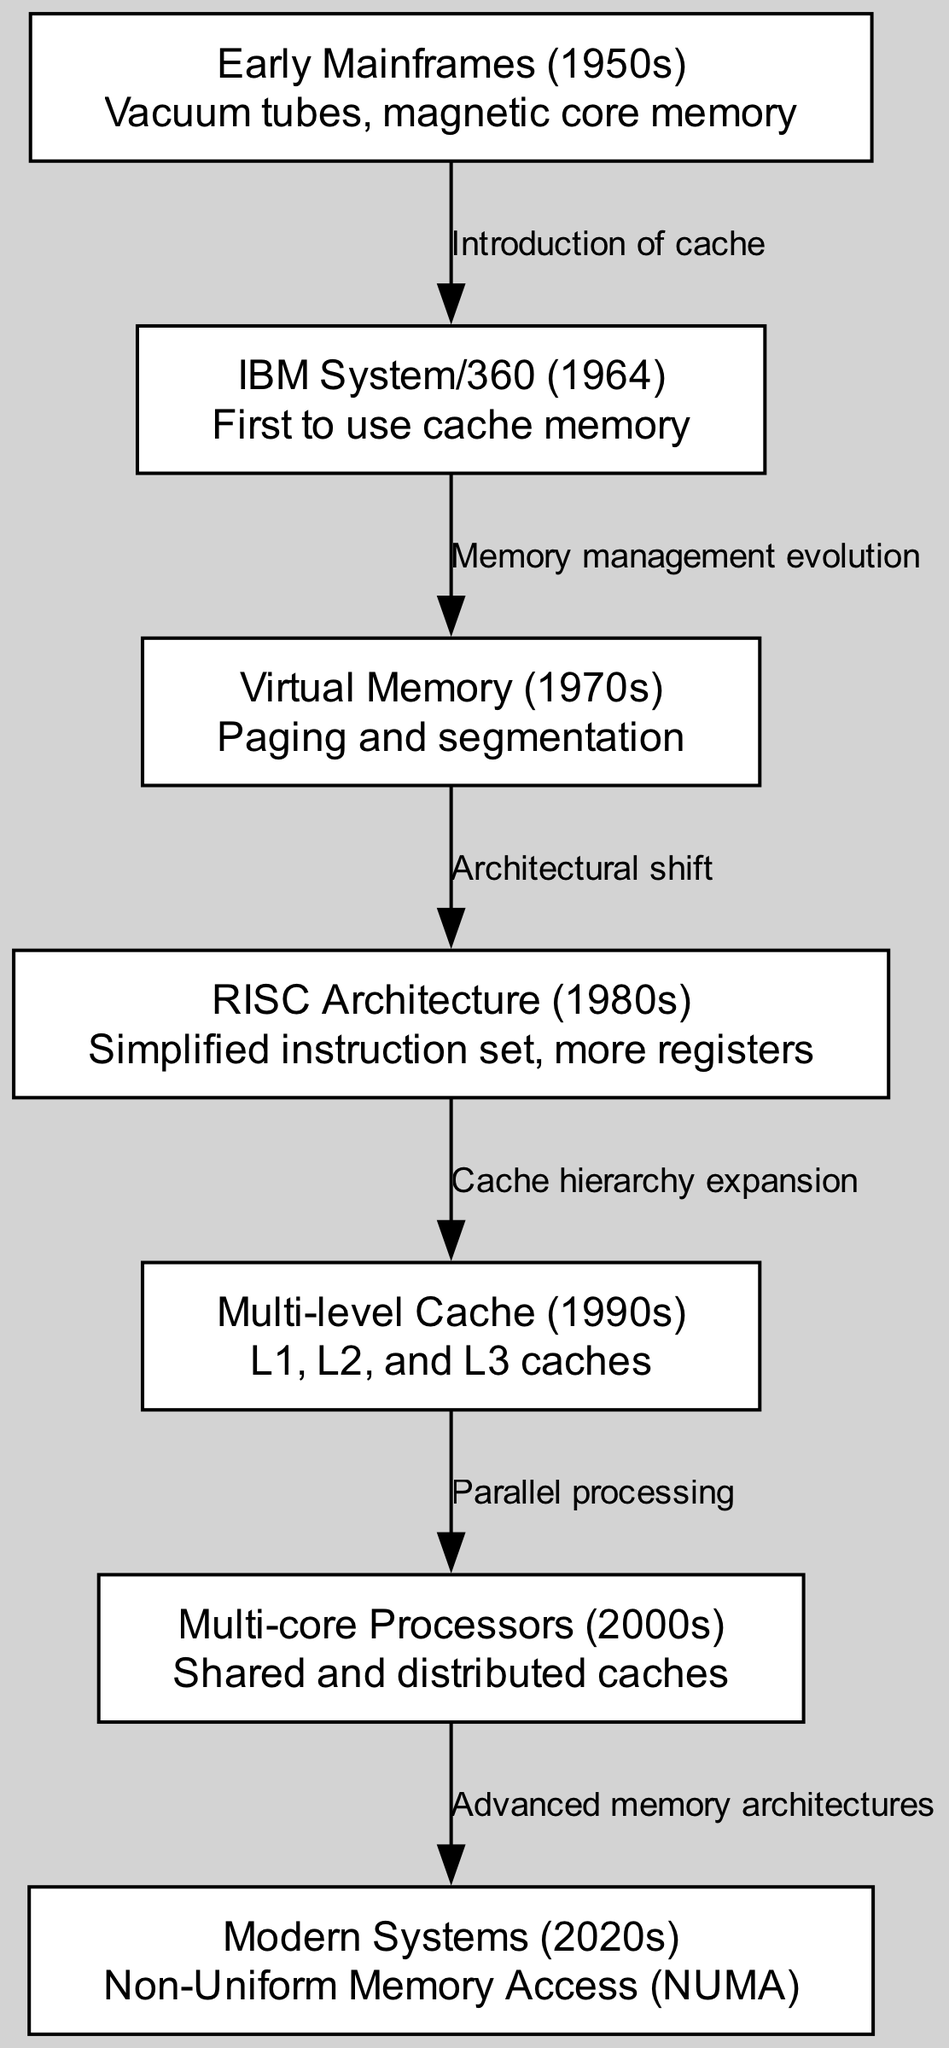What is the first memory architecture mentioned in the diagram? The diagram starts with the earliest memory architecture labeled "Early Mainframes (1950s)," which is noted for using vacuum tubes and magnetic core memory.
Answer: Early Mainframes (1950s) How many nodes are present in the diagram? By counting the nodes indicated in the data, there are a total of seven nodes representing different stages in memory hierarchy evolution.
Answer: 7 Which architecture introduced cache memory? The arrow indicates that cache memory was first introduced in the "IBM System/360 (1964)," which is drawn connected to the previous stage, Early Mainframes.
Answer: IBM System/360 (1964) What is the relationship between Virtual Memory and RISC Architecture? The diagram shows an edge labeled "Architectural shift" connecting "Virtual Memory (1970s)" to "RISC Architecture (1980s)," indicating that RISC architecture evolved from changes in virtual memory management.
Answer: Architectural shift Which evolution led to multi-core processors? The diagram connects "Multi-level Cache (1990s)" to "Multi-core Processors (2000s)" through "Parallel processing," indicating that advancements in cache hierarchy facilitated the rise of multi-core processors.
Answer: Parallel processing In which decade was Non-Uniform Memory Access first noted? The term "Non-Uniform Memory Access (NUMA)" is labeled under "Modern Systems (2020s)," indicating that it is associated with the architecture of the 2020s.
Answer: 2020s What technology was primarily used in Early Mainframes? According to the details of the first node, Early Mainframes utilized vacuum tubes and magnetic core memory as their main technology for memory.
Answer: Vacuum tubes, magnetic core memory What connects Multi-core Processors to Modern Systems? The edge labeled "Advanced memory architectures" connects "Multi-core Processors (2000s)" to "Modern Systems (2020s)," indicating that advancements in memory architectures have influenced modern systems.
Answer: Advanced memory architectures 